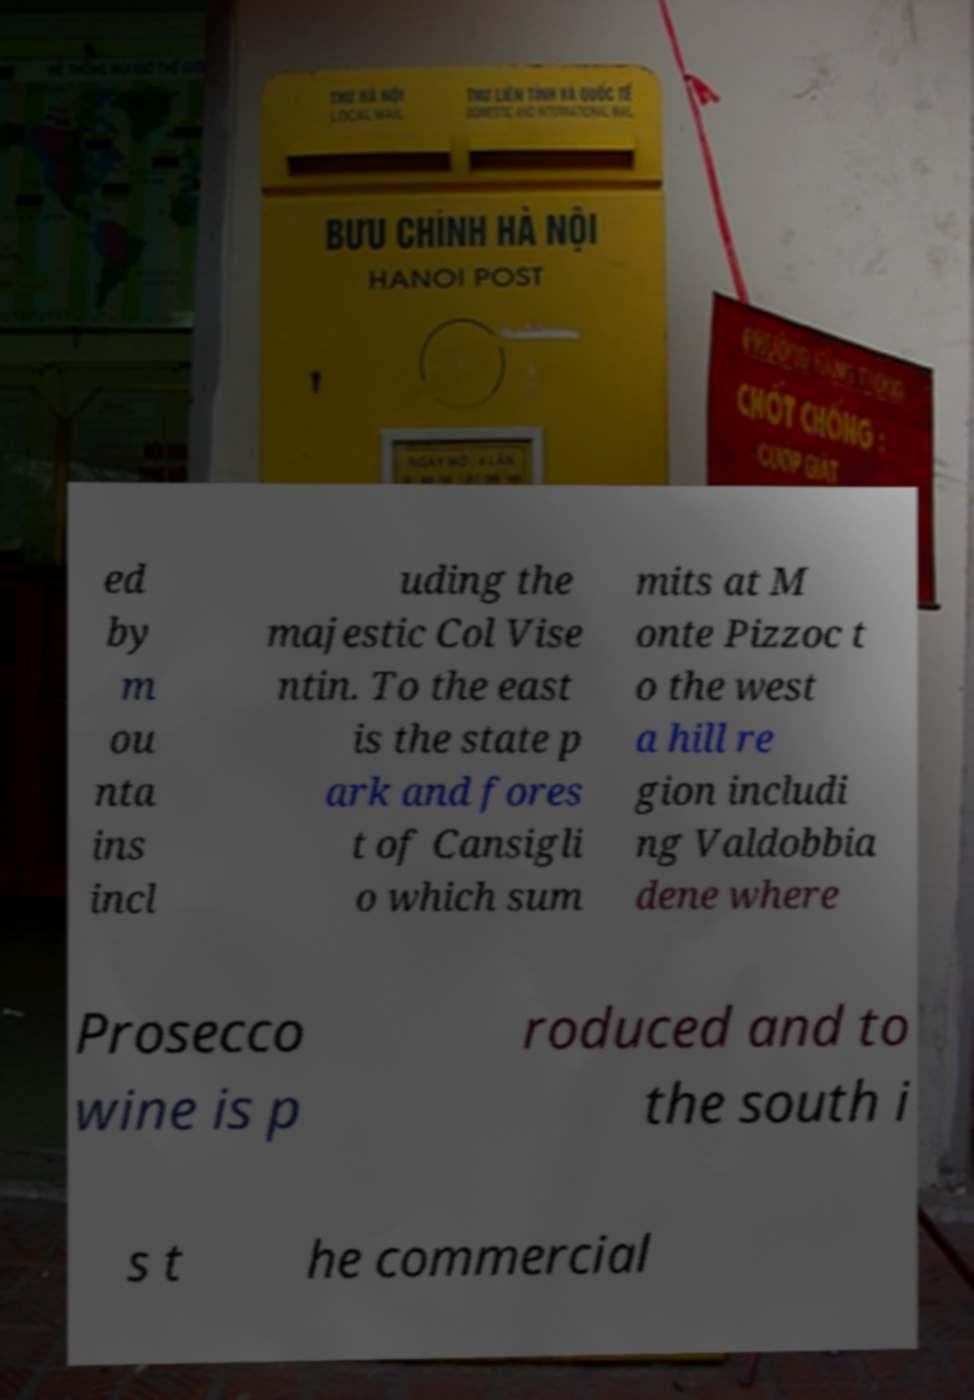There's text embedded in this image that I need extracted. Can you transcribe it verbatim? ed by m ou nta ins incl uding the majestic Col Vise ntin. To the east is the state p ark and fores t of Cansigli o which sum mits at M onte Pizzoc t o the west a hill re gion includi ng Valdobbia dene where Prosecco wine is p roduced and to the south i s t he commercial 